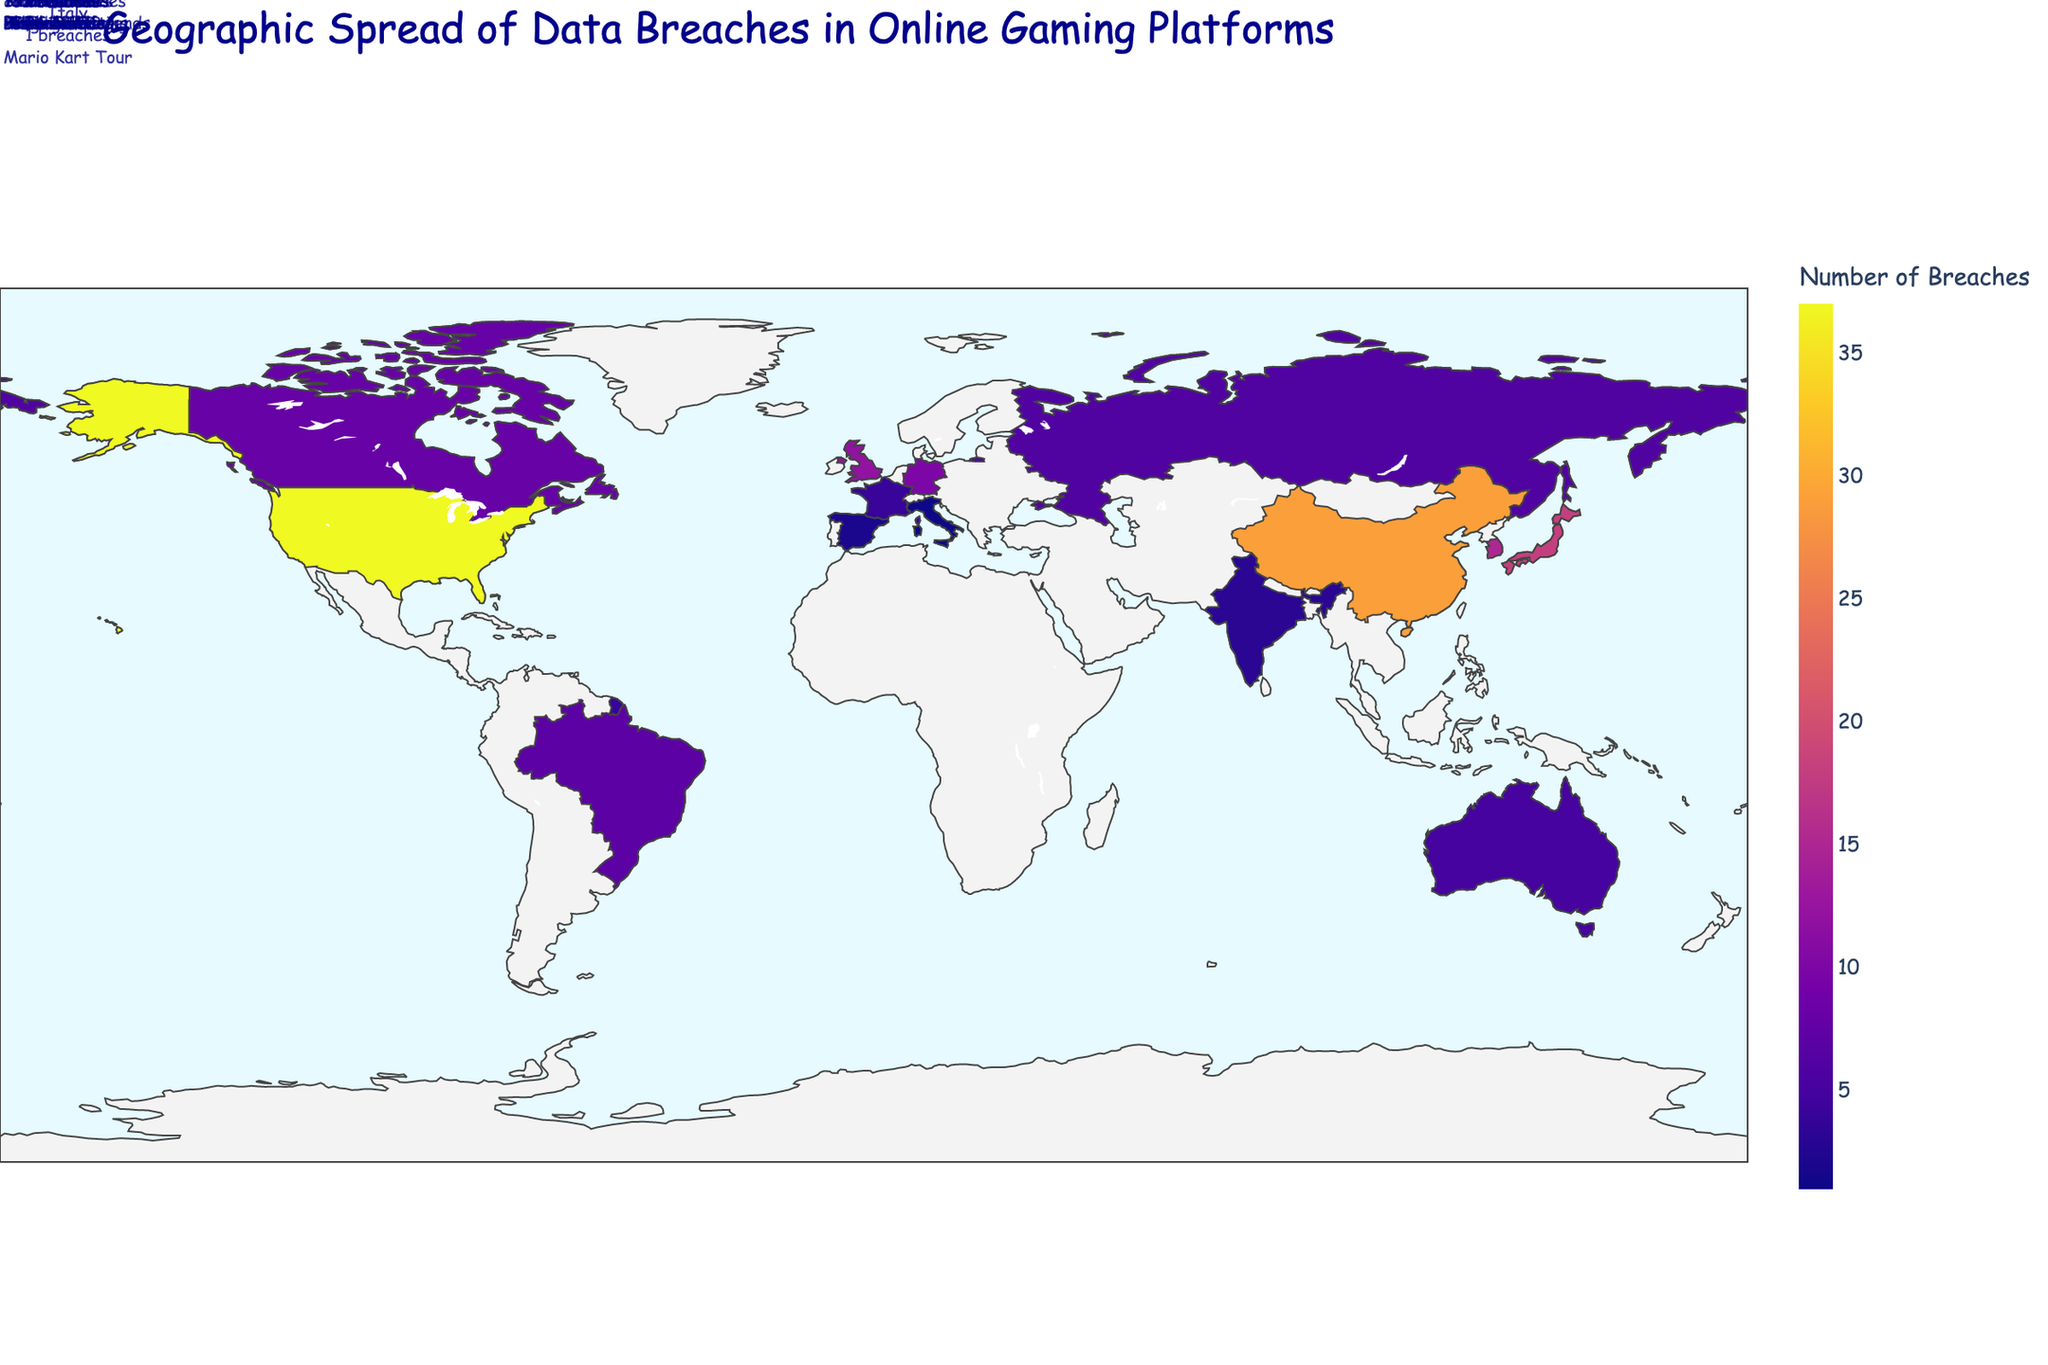What's the title of the figure? The title is usually displayed at the top of a plot to provide an overview of what the plot represents. In this figure, the title should describe the content related to data breaches and gaming platforms.
Answer: Geographic Spread of Data Breaches in Online Gaming Platforms Which country has the highest number of data breaches? The color intensity or a specific note in the figure usually indicates the number of data breaches. The United States is likely represented with the most intense color or the largest number displayed.
Answer: United States What is the most affected game in Japan? Japan’s entry in the figure will highlight the most affected game associated with it, often shown through a hover tooltip or a note.
Answer: Pokemon GO How many more data breaches does China have than Germany? Find the number of data breaches for each country in the figure, then subtract Germany's count from China’s. China has 29 breaches and Germany has 10 breaches. 29 - 10 = 19
Answer: 19 What is the total number of data breaches across all countries? To find the total, sum the number of breaches from every country listed in the figure. 37 + 29 + 18 + 15 + 12 + 10 + 8 + 7 + 6 + 5 + 4 + 3 + 2 + 1 = 157
Answer: 157 Which country has fewer data breaches, Brazil or Canada, and by how many? Look at the number of breaches for Brazil and Canada, and compare them. Canada has 8 breaches and Brazil has 7 breaches. 8 - 7 = 1
Answer: Brazil, by 1 How does the number of data breaches in Australia compare to France? Compare the numbers for these two countries from the figure. Australia has 5 breaches and France has 4 breaches. 5 - 4 = 1
Answer: Australia has 1 more breach What game is most affected in the United Kingdom? Look for the United Kingdom entry in the figure, which will show the game most affected there.
Answer: Minecraft What is the average number of breaches per country? To find the average, sum all breaches and divide by the number of countries. Total breaches = 157, Total countries = 14. 157 / 14 ≈ 11.21
Answer: Approximately 11.21 How many countries have 10 or more data breaches? Count the countries in the figure with breaches greater than or equal to 10. Countries: United States, China, Japan, South Korea, United Kingdom, Germany.
Answer: 6 